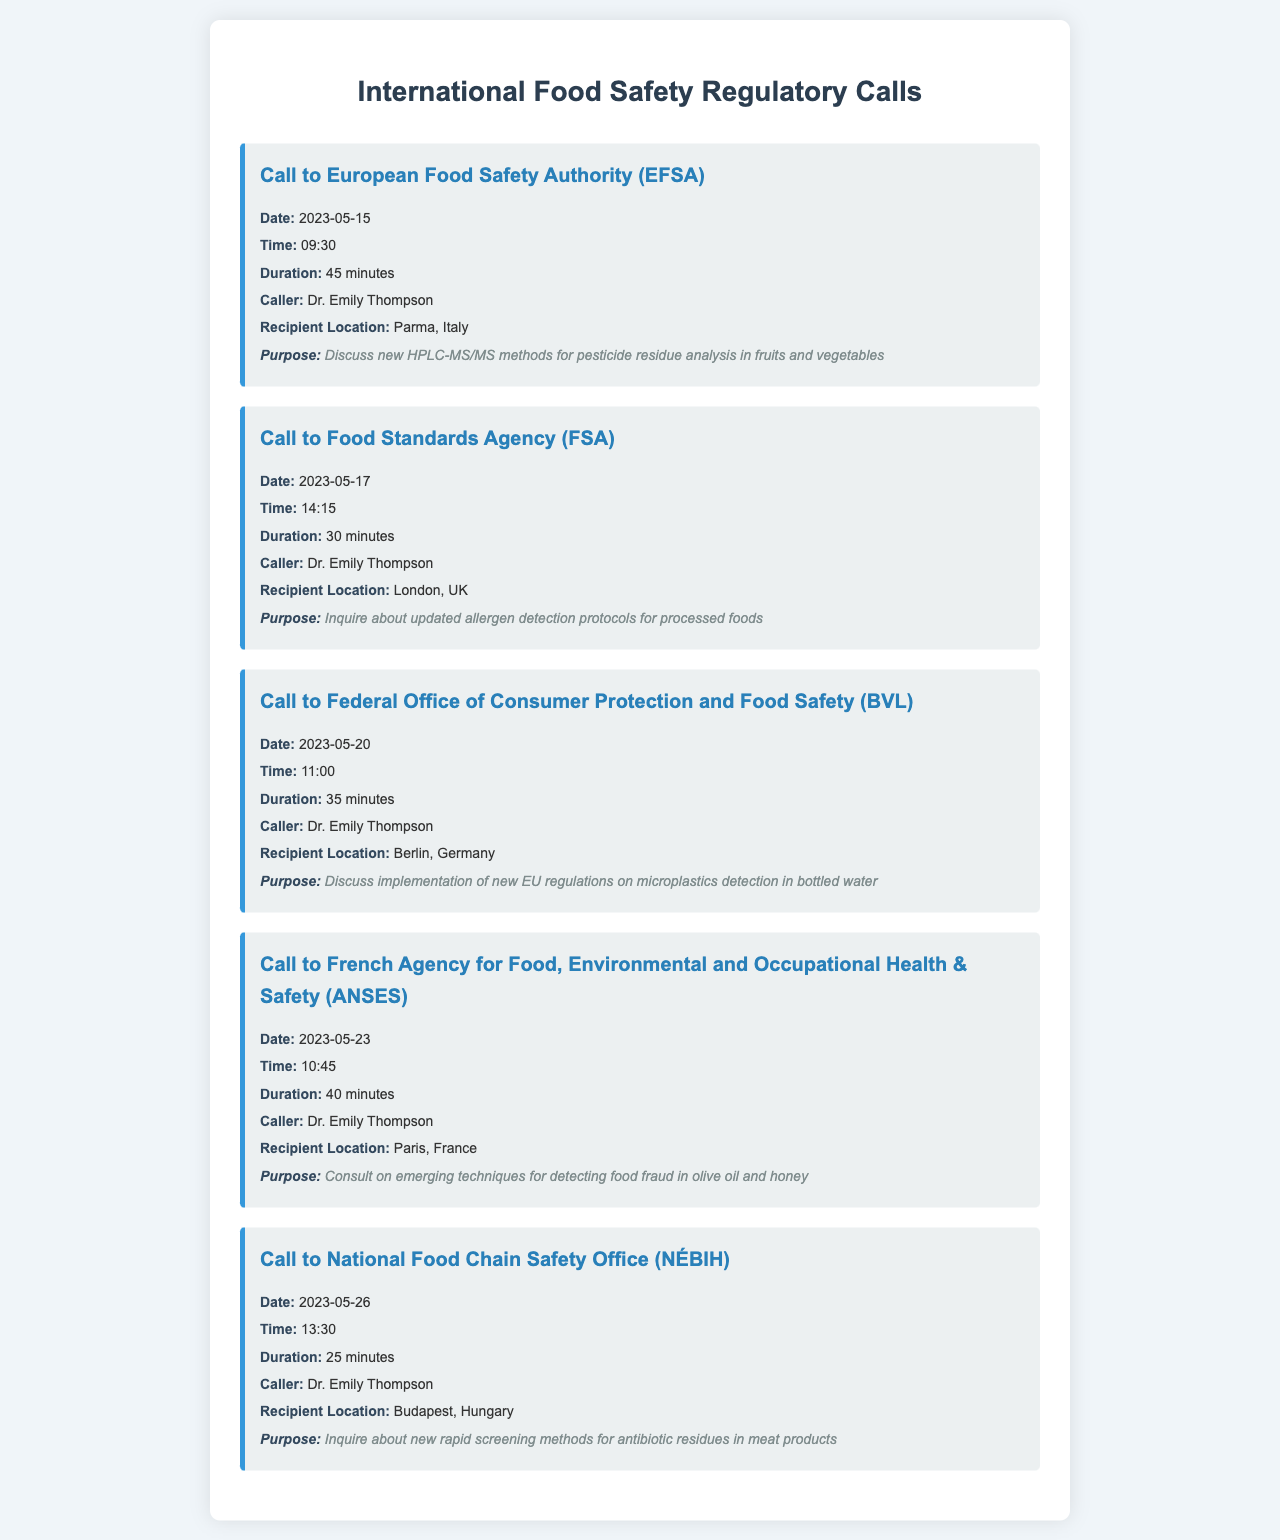What is the date of the call to the European Food Safety Authority? The date of the call is specified as May 15, 2023 in the document.
Answer: May 15, 2023 Who was the caller for all the recorded calls? The document provides the name of the caller, which is Dr. Emily Thompson for each call listed.
Answer: Dr. Emily Thompson How long was the call to the Food Standards Agency? The document mentions the duration for this specific call as 30 minutes.
Answer: 30 minutes What was the purpose of the call to the Federal Office of Consumer Protection and Food Safety? The document clearly states the purpose of the call is to discuss implementation of new EU regulations on microplastics detection in bottled water.
Answer: Discuss implementation of new EU regulations on microplastics detection in bottled water Which country hosted the call regarding allergen detection protocols? The document indicates that the call regarding allergen detection protocols took place in London, UK.
Answer: London, UK How many calls were made in total? The document shows a list of five calls made by Dr. Emily Thompson.
Answer: Five What was the recipient location for the call about new rapid screening methods? The document lists Budapest, Hungary as the recipient location for this inquiry call.
Answer: Budapest, Hungary What is the duration of the longest call recorded? The longest call mentioned in the document was to the European Food Safety Authority, lasting 45 minutes.
Answer: 45 minutes What technique was discussed in the call to ANSES? The document states that the call involved consulting on emerging techniques for detecting food fraud in olive oil and honey.
Answer: Food fraud detection techniques in olive oil and honey 